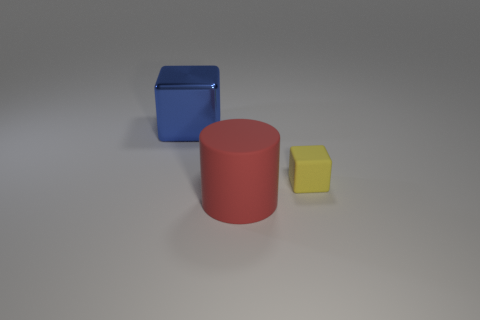Add 2 big green metallic cylinders. How many objects exist? 5 Subtract all cubes. How many objects are left? 1 Add 2 shiny cubes. How many shiny cubes are left? 3 Add 1 blue rubber things. How many blue rubber things exist? 1 Subtract 0 yellow spheres. How many objects are left? 3 Subtract all tiny objects. Subtract all large blue metallic cubes. How many objects are left? 1 